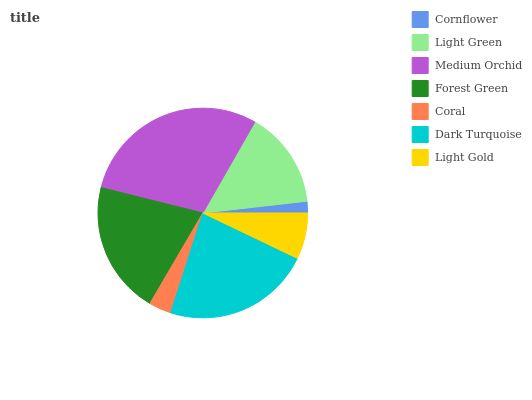Is Cornflower the minimum?
Answer yes or no. Yes. Is Medium Orchid the maximum?
Answer yes or no. Yes. Is Light Green the minimum?
Answer yes or no. No. Is Light Green the maximum?
Answer yes or no. No. Is Light Green greater than Cornflower?
Answer yes or no. Yes. Is Cornflower less than Light Green?
Answer yes or no. Yes. Is Cornflower greater than Light Green?
Answer yes or no. No. Is Light Green less than Cornflower?
Answer yes or no. No. Is Light Green the high median?
Answer yes or no. Yes. Is Light Green the low median?
Answer yes or no. Yes. Is Coral the high median?
Answer yes or no. No. Is Dark Turquoise the low median?
Answer yes or no. No. 